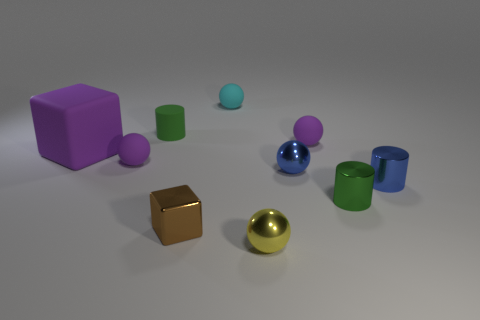There is a small metallic object that is the same color as the small rubber cylinder; what is its shape?
Provide a succinct answer. Cylinder. Are there any other cylinders of the same color as the small matte cylinder?
Give a very brief answer. Yes. What size is the metal cylinder that is the same color as the small matte cylinder?
Provide a succinct answer. Small. Is the size of the green rubber object the same as the matte cube?
Your answer should be compact. No. What number of rubber spheres have the same color as the large matte block?
Offer a terse response. 2. Is the number of yellow shiny balls greater than the number of tiny metal things?
Ensure brevity in your answer.  No. Do the yellow shiny object and the small shiny thing that is to the left of the small yellow shiny object have the same shape?
Offer a terse response. No. What is the small blue cylinder made of?
Make the answer very short. Metal. What is the color of the small shiny ball that is behind the metallic cylinder that is behind the small green cylinder right of the cyan ball?
Your answer should be compact. Blue. There is a blue thing that is the same shape as the small cyan object; what material is it?
Offer a terse response. Metal. 